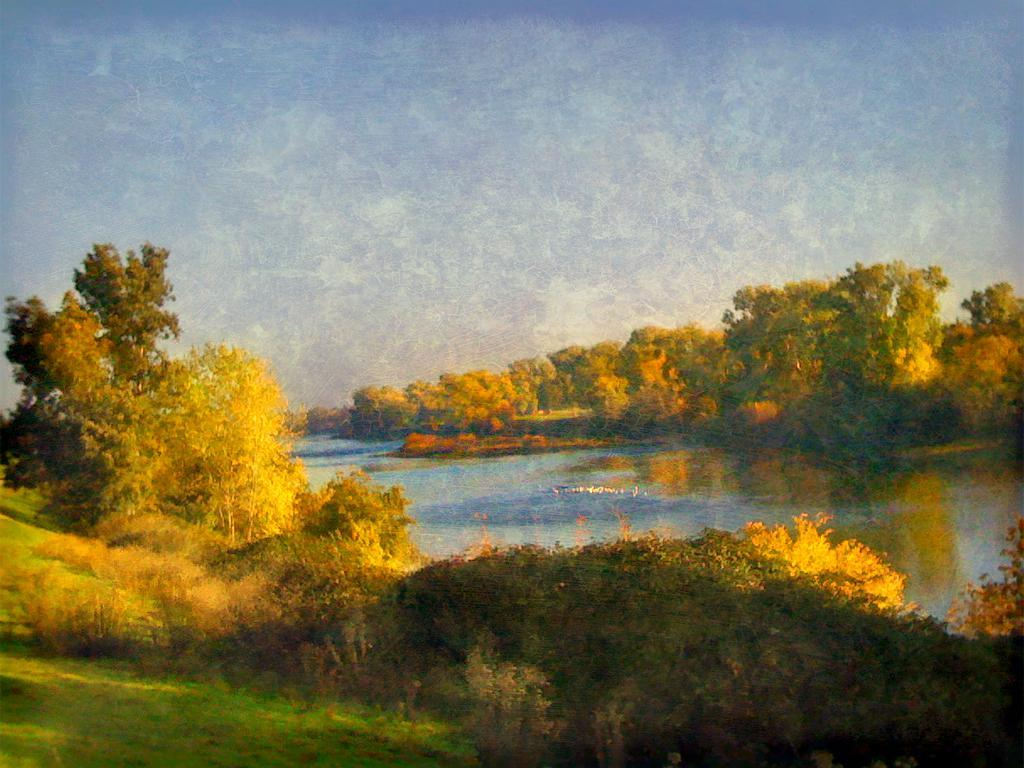What type of vegetation can be seen in the image? There are trees and plants in the image. What is covering the ground in the image? There is grass on the ground in the image. Is there any water visible in the image? Yes, there is water visible in the image. What type of beef can be seen hanging from the trees in the image? There is no beef present in the image; it features trees, plants, grass, and water. Can you tell me how many cans of soda are visible in the image? There are no cans of soda present in the image. 